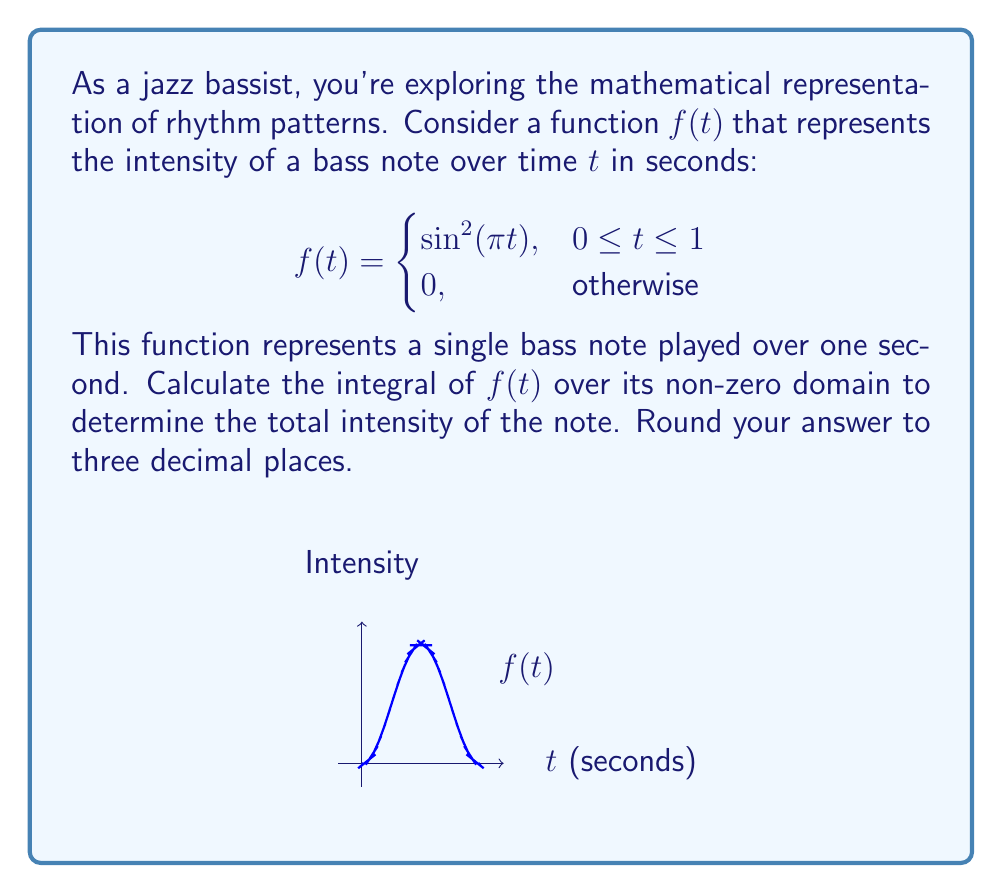Show me your answer to this math problem. Let's approach this step-by-step:

1) We need to integrate $f(t)$ over the interval $[0,1]$, as this is where the function is non-zero:

   $$\int_0^1 f(t) dt = \int_0^1 \sin^2(\pi t) dt$$

2) To integrate $\sin^2(\pi t)$, we can use the trigonometric identity:
   
   $$\sin^2 x = \frac{1 - \cos(2x)}{2}$$

3) Applying this to our integral:

   $$\int_0^1 \sin^2(\pi t) dt = \int_0^1 \frac{1 - \cos(2\pi t)}{2} dt$$

4) Now we can split this into two integrals:

   $$\frac{1}{2}\int_0^1 1 dt - \frac{1}{2}\int_0^1 \cos(2\pi t) dt$$

5) The first integral is straightforward:

   $$\frac{1}{2}\int_0^1 1 dt = \frac{1}{2}t\bigg|_0^1 = \frac{1}{2}$$

6) For the second integral, we use the antiderivative of cosine:

   $$-\frac{1}{2}\int_0^1 \cos(2\pi t) dt = -\frac{1}{2}\cdot\frac{1}{2\pi}\sin(2\pi t)\bigg|_0^1$$

7) Evaluating this:

   $$-\frac{1}{4\pi}[\sin(2\pi) - \sin(0)] = 0$$

   (since $\sin(2\pi) = \sin(0) = 0$)

8) Therefore, our final result is:

   $$\frac{1}{2} - 0 = \frac{1}{2} = 0.5$$

9) Rounding to three decimal places: 0.500
Answer: 0.500 